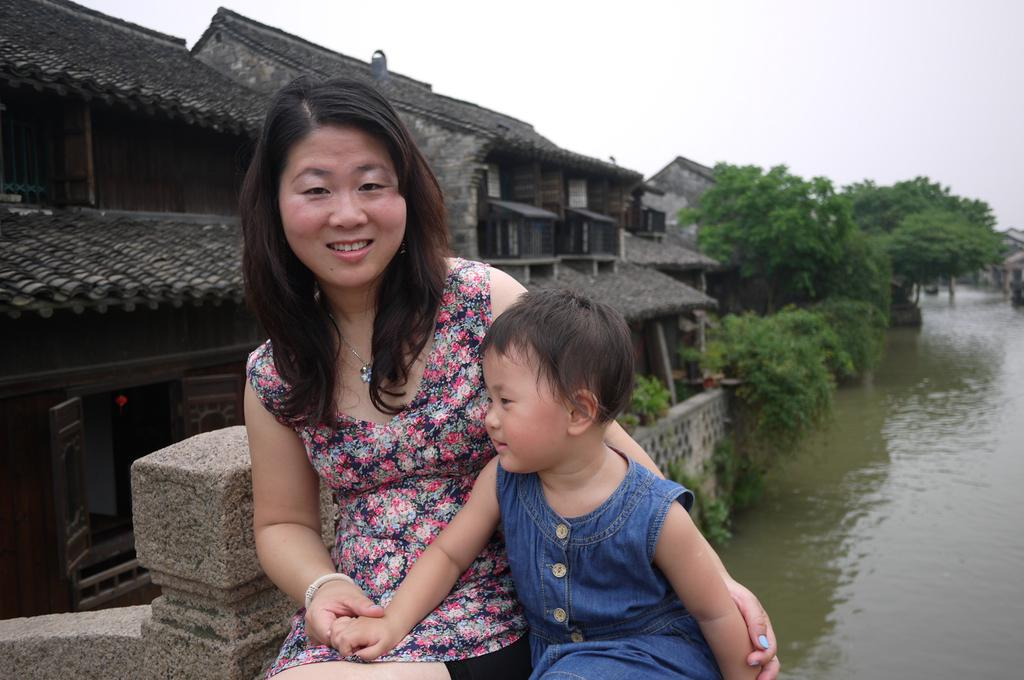What type of structures can be seen in the image? There are houses in the image. What natural element is present in the image? There is a tree in the image. What body of water is visible in the image? There is water visible in the image. How many people are in the image? There are two people standing in the front of the image. What is visible at the top of the image? The sky is visible at the top of the image. What type of songs can be heard coming from the tree in the image? There are no songs coming from the tree in the image, as trees do not produce sounds. Is there a bulb visible in the image? There is no bulb present in the image. Can you see a volcano in the image? There is no volcano present in the image. 